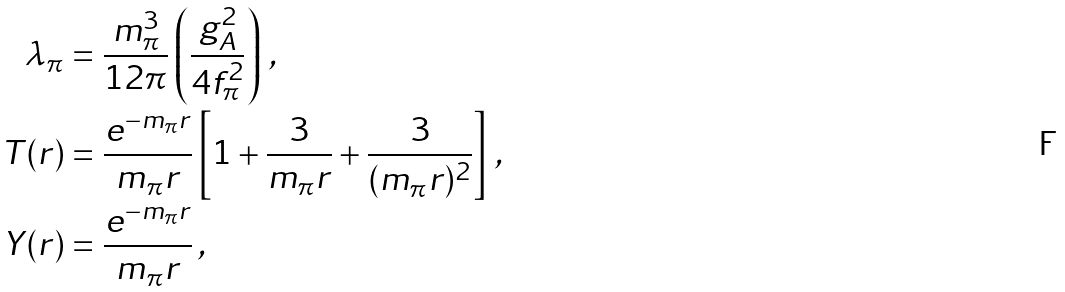<formula> <loc_0><loc_0><loc_500><loc_500>\lambda _ { \pi } & = \frac { m _ { \pi } ^ { 3 } } { 1 2 \pi } \left ( \frac { g _ { A } ^ { 2 } } { 4 f _ { \pi } ^ { 2 } } \right ) \, , \\ T ( r ) & = \frac { e ^ { - m _ { \pi } r } } { m _ { \pi } r } \left [ 1 + \frac { 3 } { m _ { \pi } r } + \frac { 3 } { ( m _ { \pi } r ) ^ { 2 } } \right ] \, , \\ Y ( r ) & = \frac { e ^ { - m _ { \pi } r } } { m _ { \pi } r } \, ,</formula> 